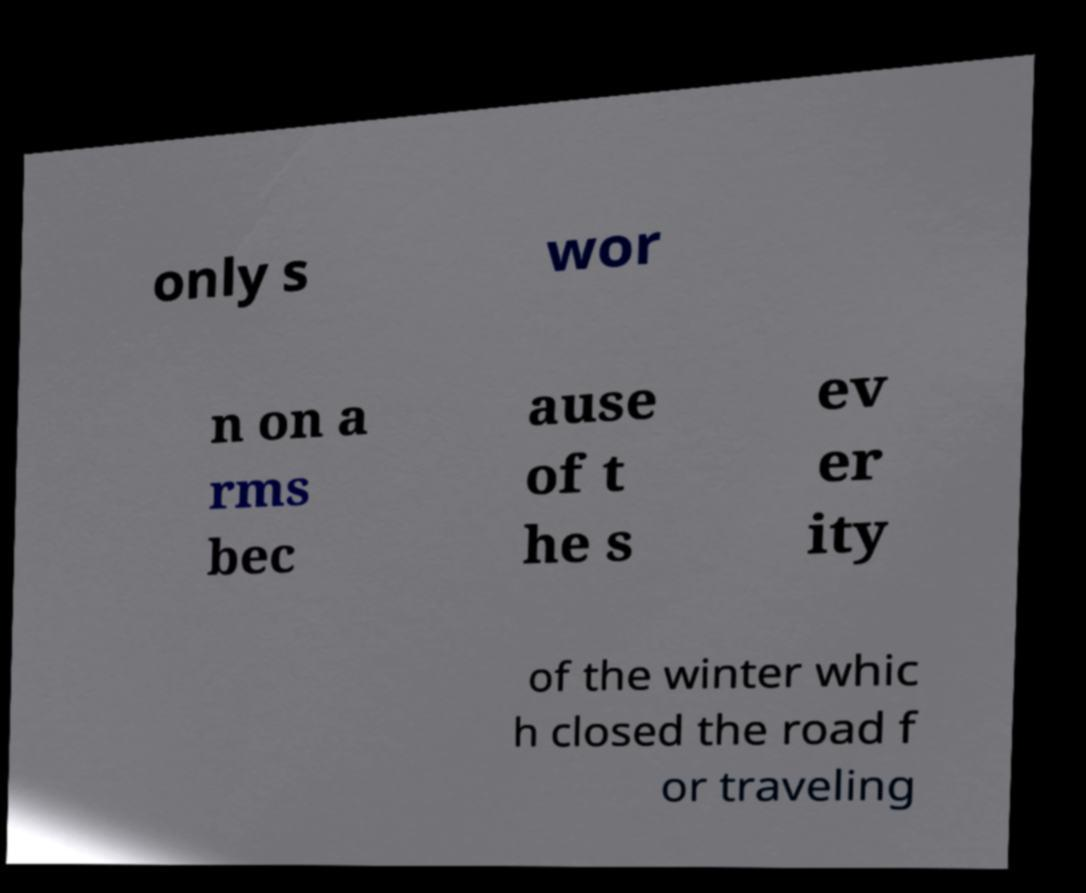Could you extract and type out the text from this image? only s wor n on a rms bec ause of t he s ev er ity of the winter whic h closed the road f or traveling 